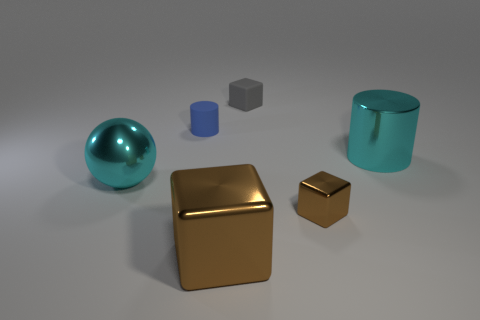How many brown cubes must be subtracted to get 1 brown cubes? 1 Subtract all tiny blocks. How many blocks are left? 1 Subtract 2 cylinders. How many cylinders are left? 0 Add 4 yellow balls. How many objects exist? 10 Subtract all blue cylinders. How many cylinders are left? 1 Subtract 0 blue blocks. How many objects are left? 6 Subtract all balls. How many objects are left? 5 Subtract all gray blocks. Subtract all red balls. How many blocks are left? 2 Subtract all gray balls. How many red blocks are left? 0 Subtract all small blue matte balls. Subtract all gray blocks. How many objects are left? 5 